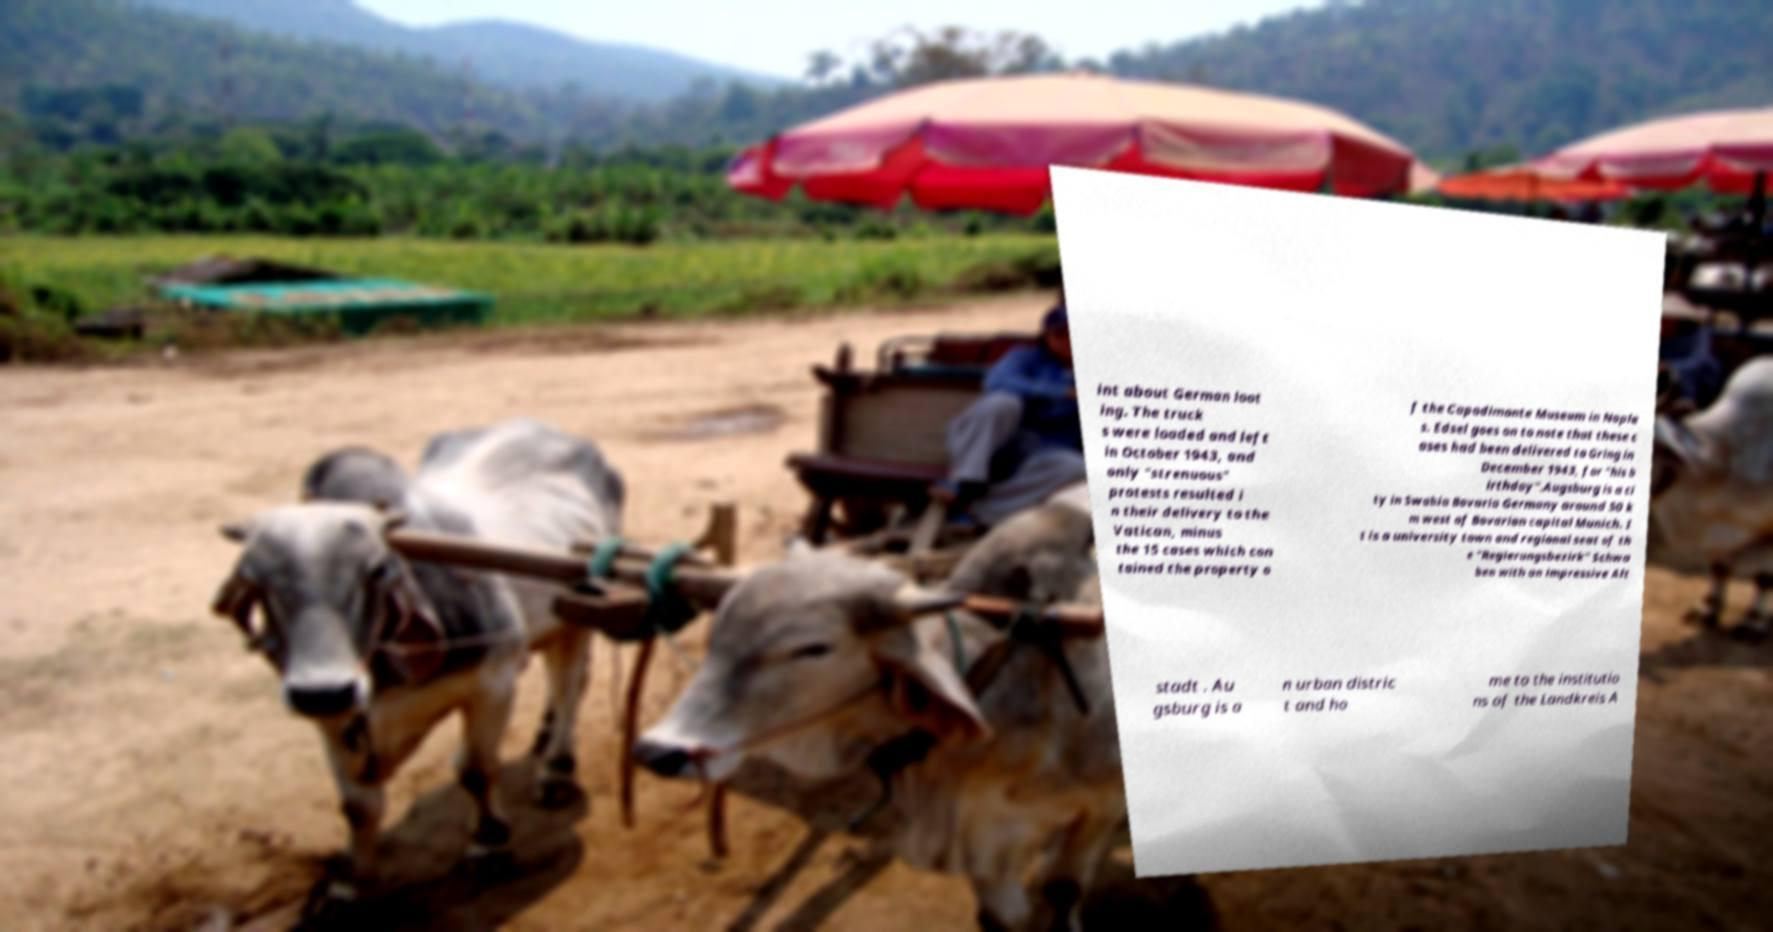Please read and relay the text visible in this image. What does it say? int about German loot ing. The truck s were loaded and left in October 1943, and only "strenuous" protests resulted i n their delivery to the Vatican, minus the 15 cases which con tained the property o f the Capodimonte Museum in Naple s. Edsel goes on to note that these c ases had been delivered to Gring in December 1943, for "his b irthday".Augsburg is a ci ty in Swabia Bavaria Germany around 50 k m west of Bavarian capital Munich. I t is a university town and regional seat of th e "Regierungsbezirk" Schwa ben with an impressive Alt stadt . Au gsburg is a n urban distric t and ho me to the institutio ns of the Landkreis A 